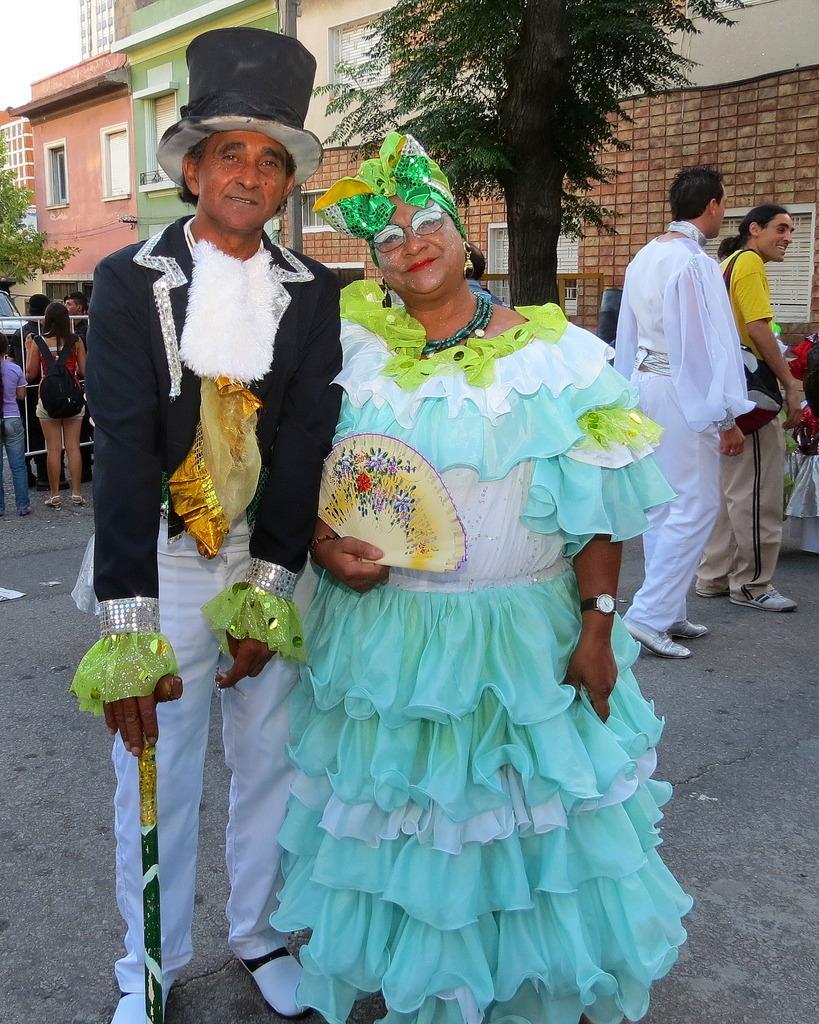Can you describe this image briefly? In the center of the image we can see a man and a woman standing on the road wearing a costume. In that a man is holding a stick and the woman is holding a hand fan. On the backside we can see a group of people standing. We can also see a fence, trees, a car, a building with windows and the sky. 